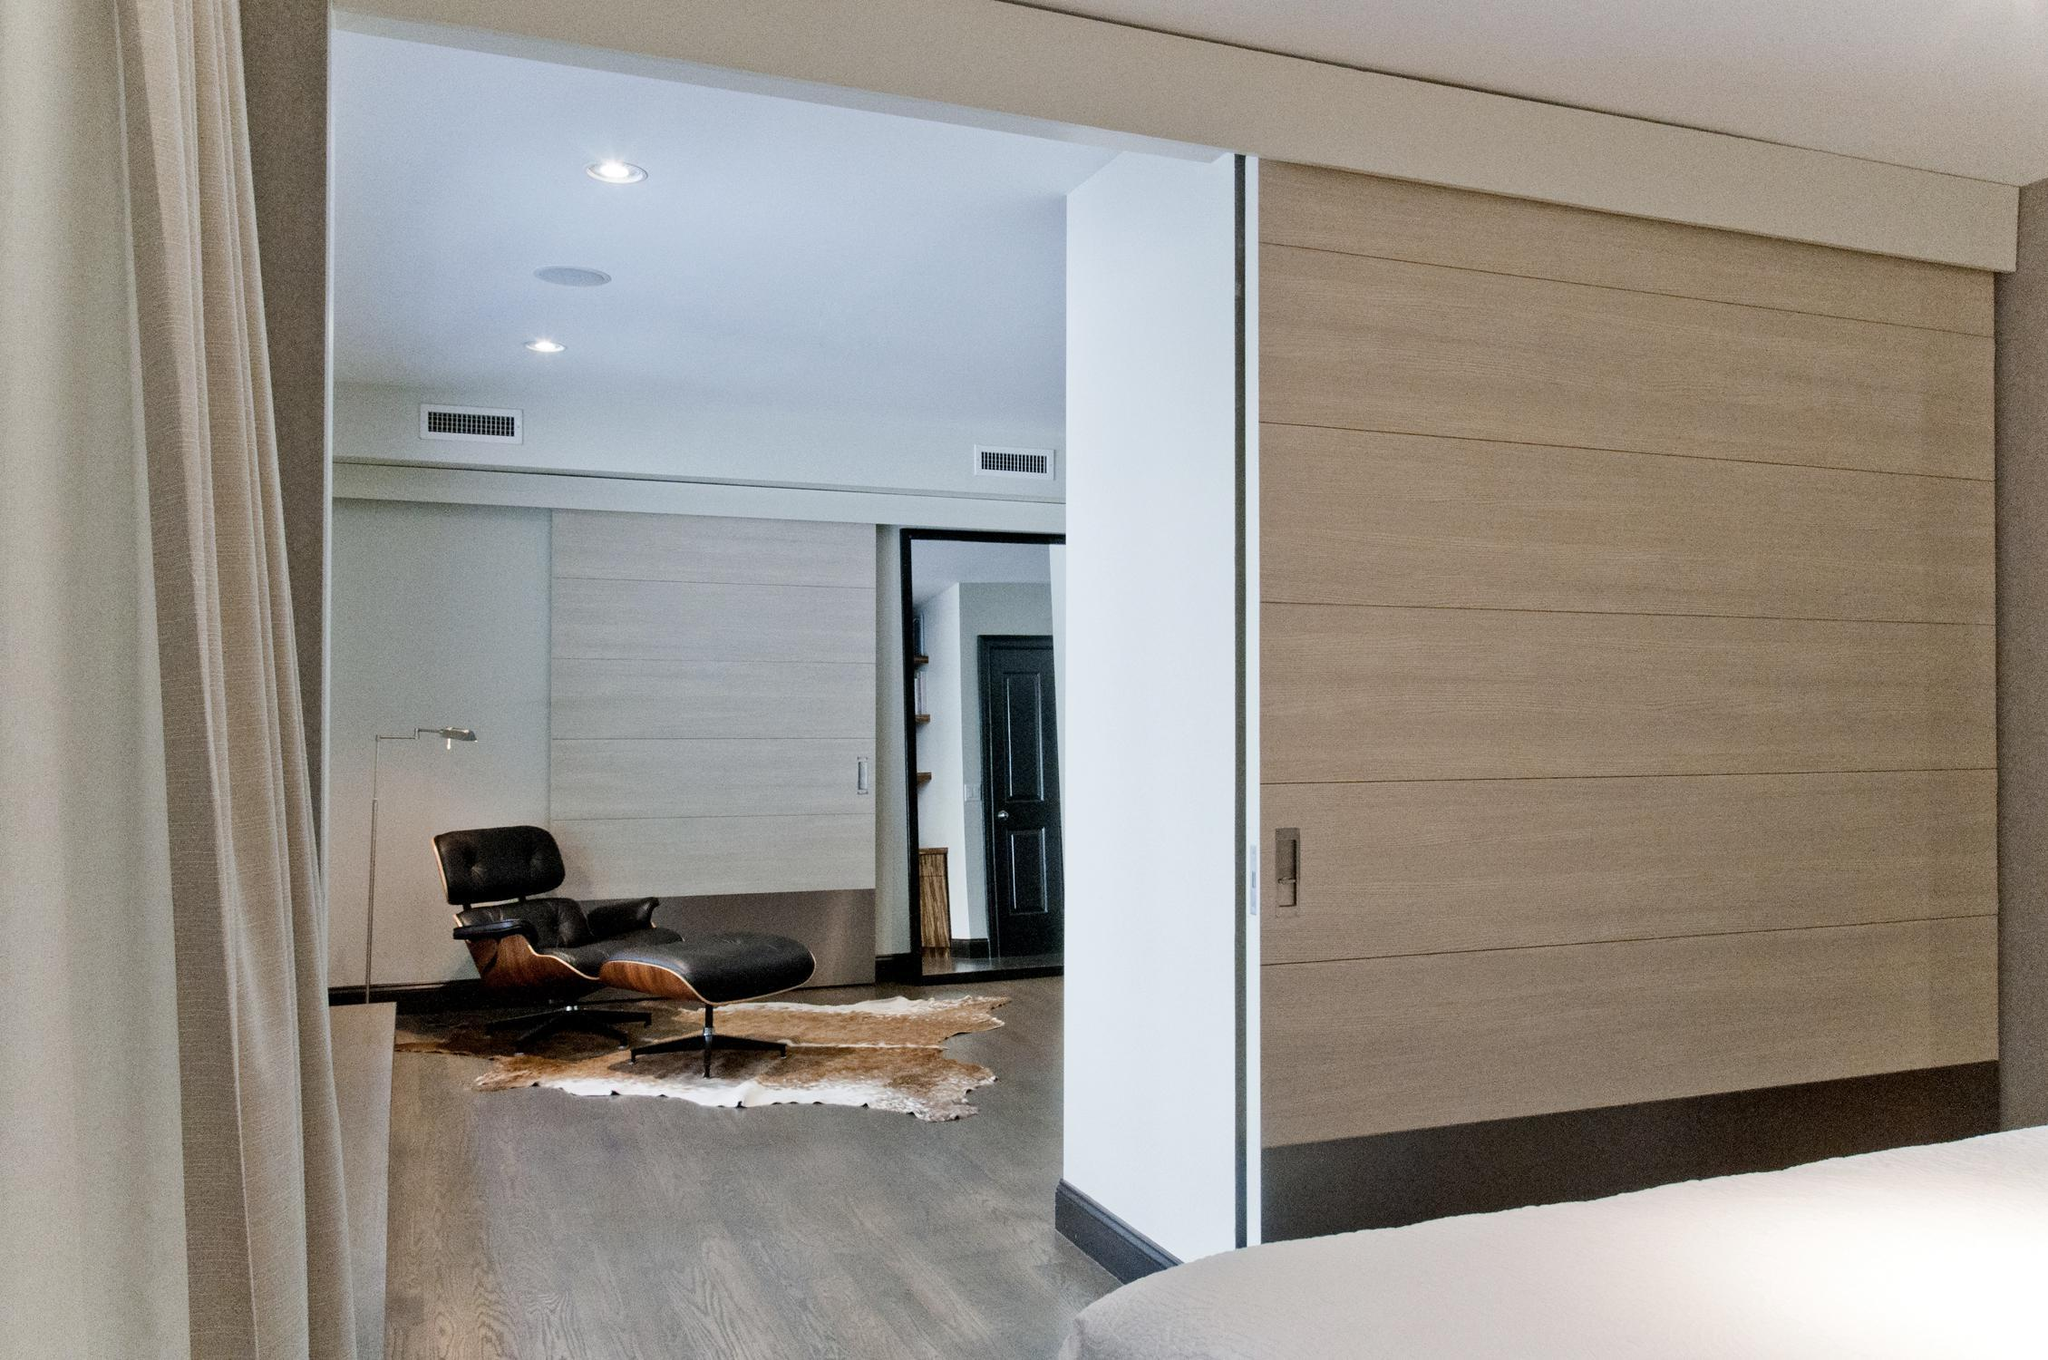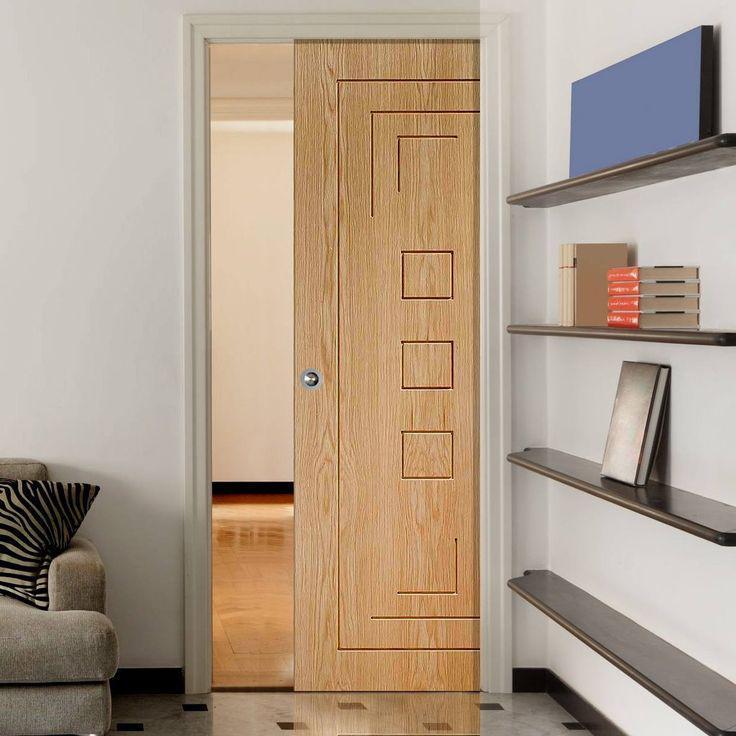The first image is the image on the left, the second image is the image on the right. Analyze the images presented: Is the assertion "In at  least one image there is a half open light brown wooden door that opens from the right." valid? Answer yes or no. Yes. The first image is the image on the left, the second image is the image on the right. Evaluate the accuracy of this statement regarding the images: "An image shows solid white sliding doors that open into a room with wood furniture.". Is it true? Answer yes or no. No. 